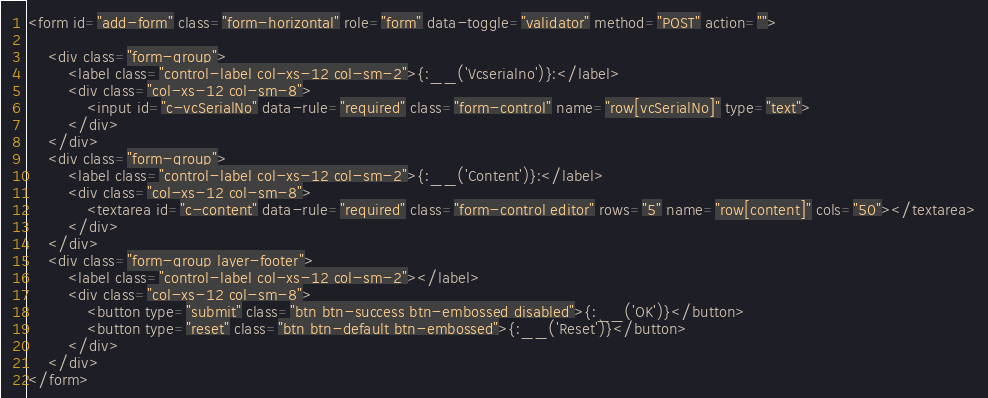Convert code to text. <code><loc_0><loc_0><loc_500><loc_500><_HTML_><form id="add-form" class="form-horizontal" role="form" data-toggle="validator" method="POST" action="">

    <div class="form-group">
        <label class="control-label col-xs-12 col-sm-2">{:__('Vcserialno')}:</label>
        <div class="col-xs-12 col-sm-8">
            <input id="c-vcSerialNo" data-rule="required" class="form-control" name="row[vcSerialNo]" type="text">
        </div>
    </div>
    <div class="form-group">
        <label class="control-label col-xs-12 col-sm-2">{:__('Content')}:</label>
        <div class="col-xs-12 col-sm-8">
            <textarea id="c-content" data-rule="required" class="form-control editor" rows="5" name="row[content]" cols="50"></textarea>
        </div>
    </div>
    <div class="form-group layer-footer">
        <label class="control-label col-xs-12 col-sm-2"></label>
        <div class="col-xs-12 col-sm-8">
            <button type="submit" class="btn btn-success btn-embossed disabled">{:__('OK')}</button>
            <button type="reset" class="btn btn-default btn-embossed">{:__('Reset')}</button>
        </div>
    </div>
</form>
</code> 